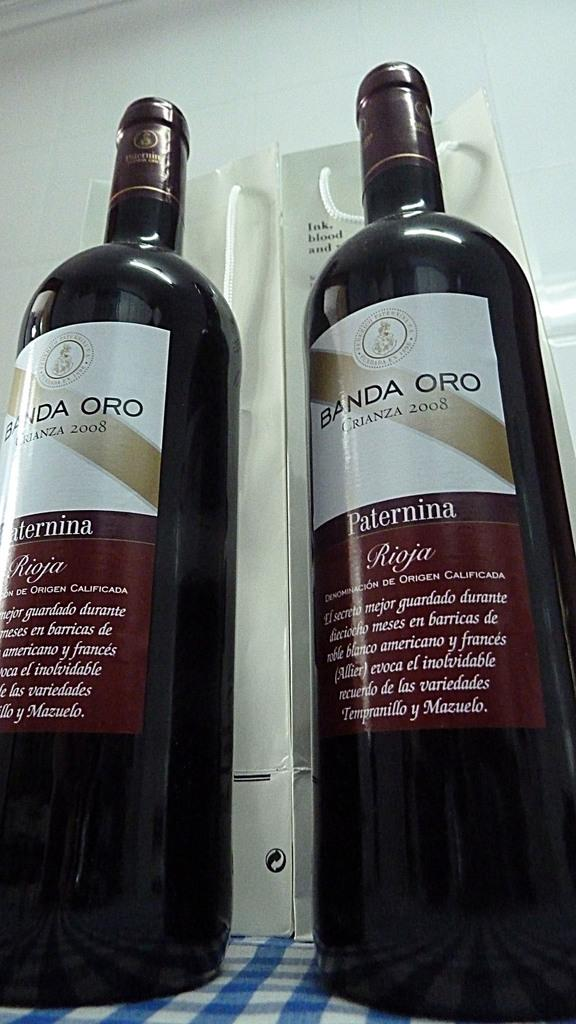How many bottles are present in the image? There are two bottles in the image. What is the bottles placed on? The bottles are on a cloth. What can be seen on the surface of the bottles? There are text and stickers on the bottles. What can be seen in the background of the image? There is a whiteboard visible in the background of the image. What type of skin condition is visible on the squirrel in the image? There is no squirrel present in the image, so it is not possible to determine if there is any skin condition. 